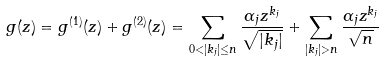<formula> <loc_0><loc_0><loc_500><loc_500>g ( z ) = g ^ { ( 1 ) } ( z ) + g ^ { ( 2 ) } ( z ) = \sum _ { 0 < | k _ { j } | \leq n } \frac { \alpha _ { j } z ^ { k _ { j } } } { \sqrt { | k _ { j } | } } + \sum _ { | k _ { j } | > n } \frac { \alpha _ { j } z ^ { k _ { j } } } { \sqrt { n } }</formula> 